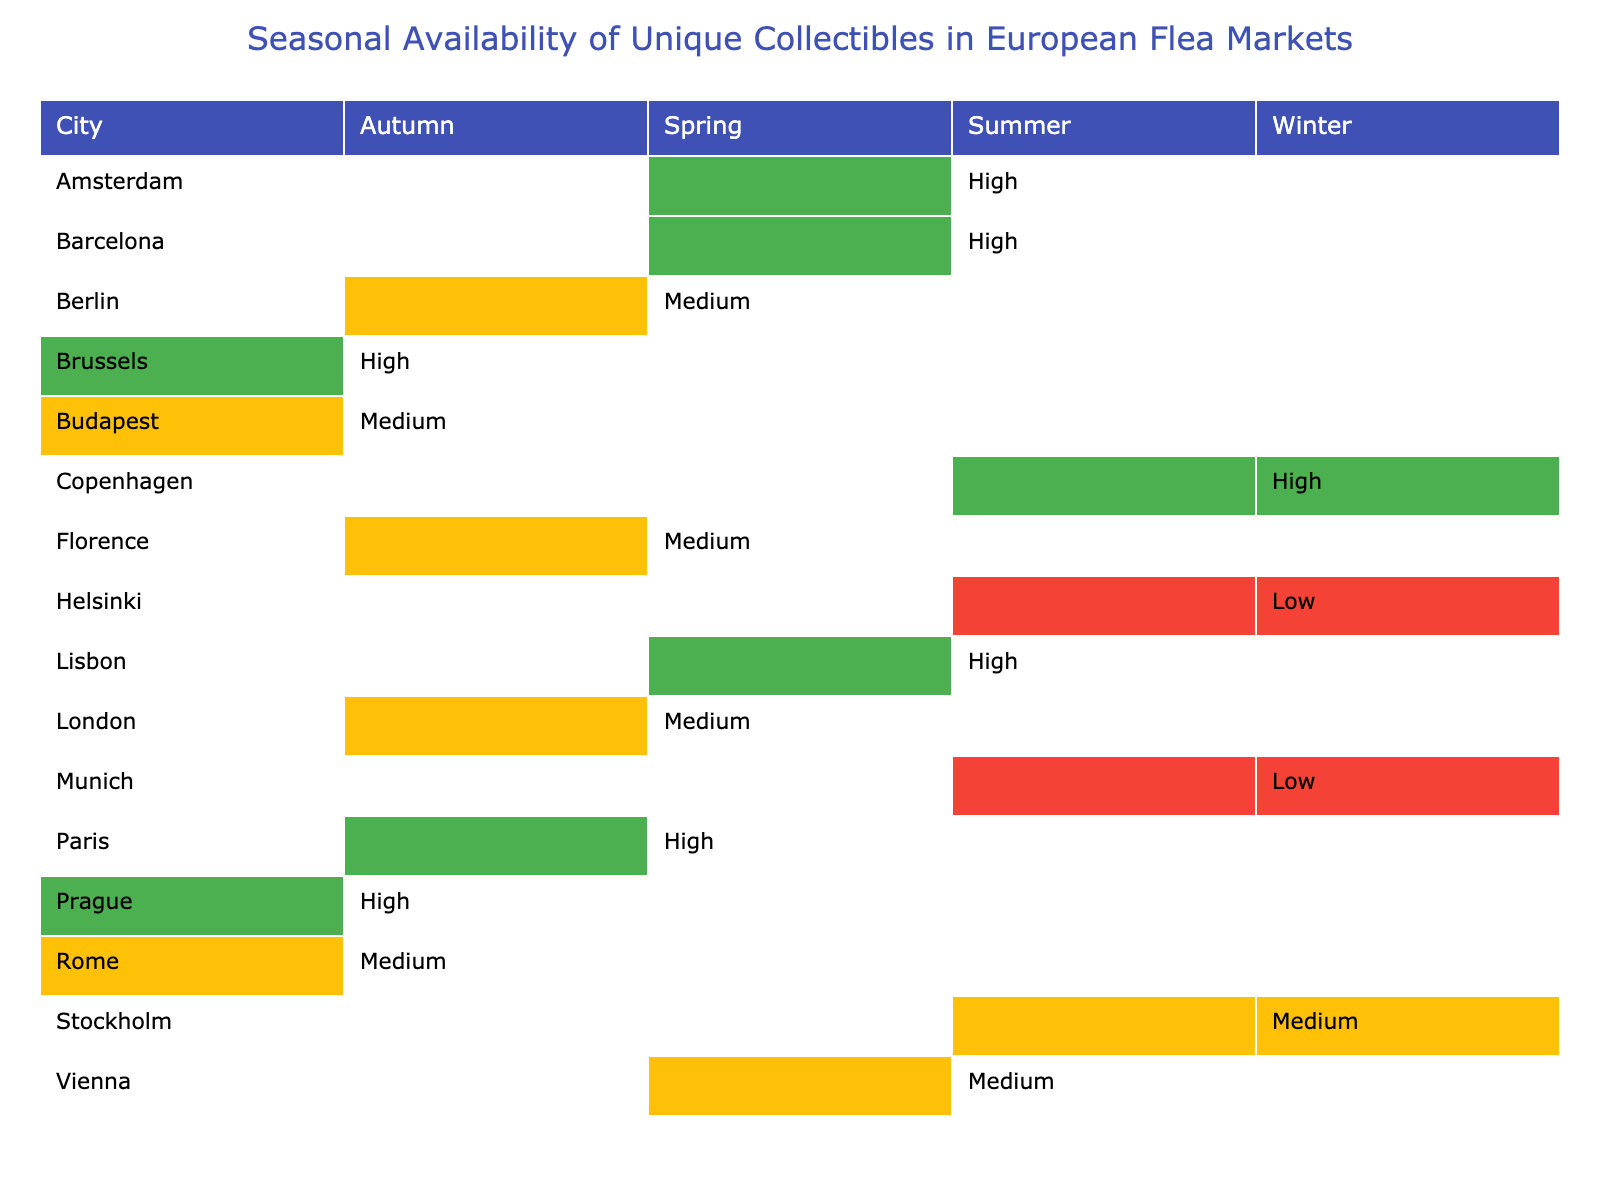What collectible has the highest availability in summer? According to the table, both Delft Blue Pottery in Amsterdam and Modernist Furniture in Barcelona have "High" availability in summer.
Answer: Delft Blue Pottery and Modernist Furniture Which city has the lowest availability for collectibles in winter? Munich has Bavarian Folk Art with "Low" availability, which is the only low availability listed for winter in the table.
Answer: Munich Is there any collectible with medium availability in autumn? Yes, there are two collectibles with medium availability in autumn: Ancient Roman Coins in Rome and Hungarian Folk Embroidery in Budapest.
Answer: Yes In which season does Prague's Havelská Market offer collectibles? According to the table, Prague's Havelská Market offers collectibles in autumn, specifically Bohemian Crystal with "High" availability.
Answer: Autumn How many cities have collectibles with high availability throughout all four seasons? By examining the table, it appears that each city has collectibles with high availability in varying seasons, and there are no cities with high availability across all four seasons.
Answer: None Which seasons do the collectibles with medium availability appear most frequently? The collectibles with medium availability appear in spring, summer, and autumn, but not in winter. Spring and autumn each have two, while summer only has one. So, spring and autumn are the most frequent seasons for medium availability.
Answer: Spring and Autumn Is there any collectible that is available in every season? Based on the information in the table, no single collectible is available in all four seasons. Each collectible is limited to a specific season.
Answer: No What is the total number of collectibles with high availability? There are four instances of "High" availability across the table: Art Nouveau Jewelry in Paris (spring), Delft Blue Pottery in Amsterdam (summer), Bohemian Crystal in Prague (autumn), and Royal Copenhagen Porcelain in Copenhagen (winter), totaling four collectibles.
Answer: Four Which city is known for its Art Nouveau collectibles? Paris is known for its Art Nouveau Jewelry with high availability during the spring season, as indicated in the table.
Answer: Paris In terms of availability, what is the difference between summertime and wintertime collectibles? In comparing availability, summer features three high items, while winter features two, with one low. So, summer offers generally better availability.
Answer: Summer has better availability 